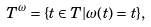<formula> <loc_0><loc_0><loc_500><loc_500>T ^ { \omega } = \{ t \in T | \omega ( t ) = t \} ,</formula> 